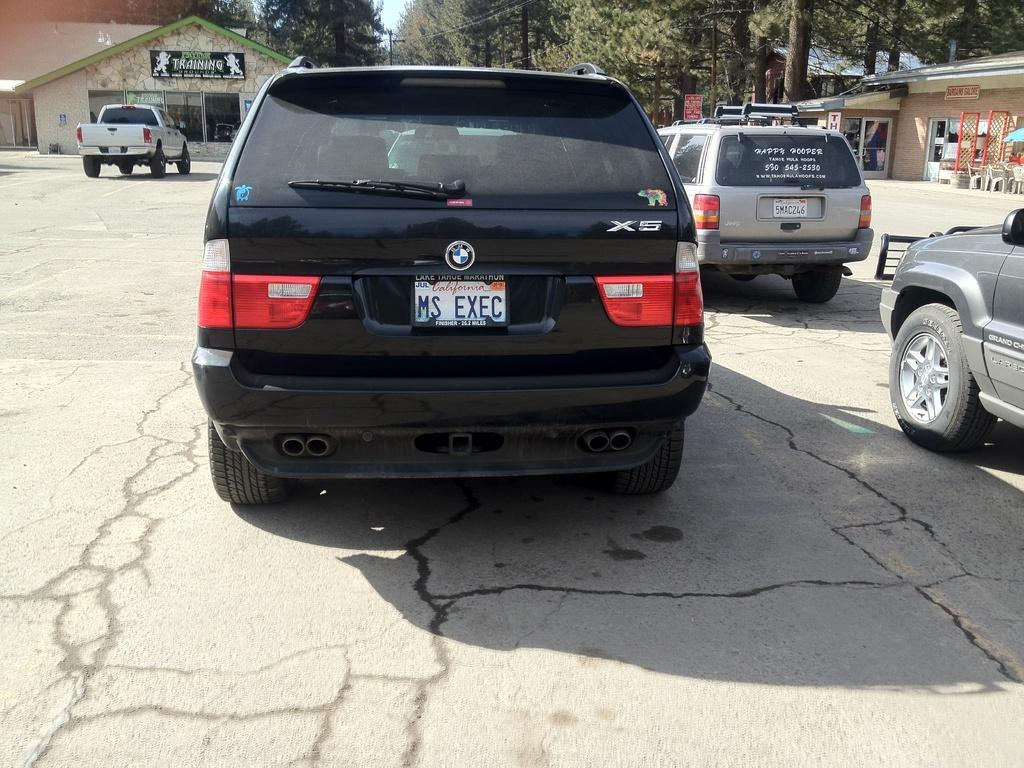<image>
Share a concise interpretation of the image provided. A black BMW SUV has the license plate Ms Exec. 